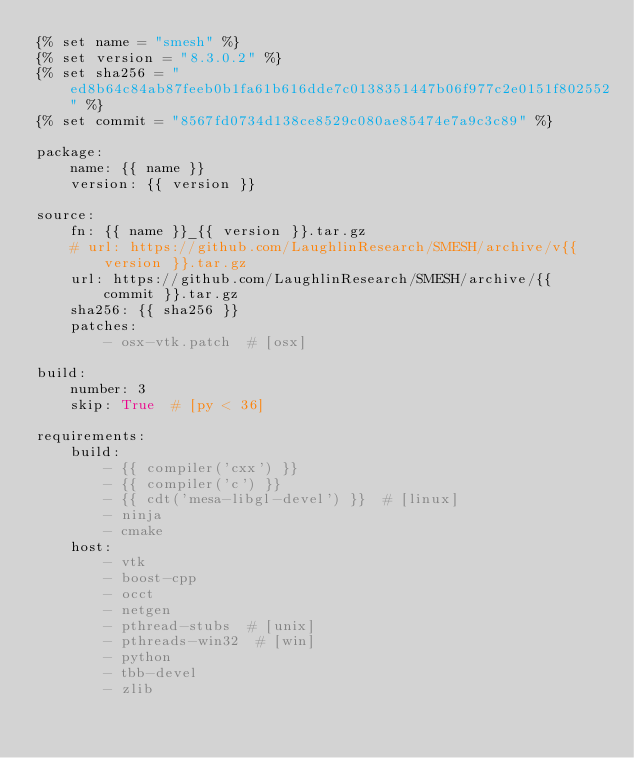Convert code to text. <code><loc_0><loc_0><loc_500><loc_500><_YAML_>{% set name = "smesh" %}
{% set version = "8.3.0.2" %}
{% set sha256 = "ed8b64c84ab87feeb0b1fa61b616dde7c0138351447b06f977c2e0151f802552" %}
{% set commit = "8567fd0734d138ce8529c080ae85474e7a9c3c89" %}

package:
    name: {{ name }}
    version: {{ version }}

source:
    fn: {{ name }}_{{ version }}.tar.gz
    # url: https://github.com/LaughlinResearch/SMESH/archive/v{{ version }}.tar.gz
    url: https://github.com/LaughlinResearch/SMESH/archive/{{ commit }}.tar.gz
    sha256: {{ sha256 }}
    patches:
        - osx-vtk.patch  # [osx]

build:
    number: 3
    skip: True  # [py < 36]

requirements:
    build:
        - {{ compiler('cxx') }}
        - {{ compiler('c') }}
        - {{ cdt('mesa-libgl-devel') }}  # [linux]
        - ninja
        - cmake
    host:
        - vtk
        - boost-cpp
        - occt
        - netgen
        - pthread-stubs  # [unix]
        - pthreads-win32  # [win]
        - python
        - tbb-devel
        - zlib</code> 